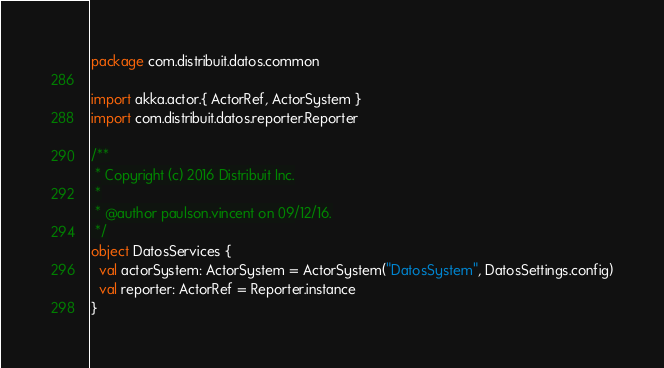<code> <loc_0><loc_0><loc_500><loc_500><_Scala_>package com.distribuit.datos.common

import akka.actor.{ ActorRef, ActorSystem }
import com.distribuit.datos.reporter.Reporter

/**
 * Copyright (c) 2016 Distribuit Inc.
 *
 * @author paulson.vincent on 09/12/16.
 */
object DatosServices {
  val actorSystem: ActorSystem = ActorSystem("DatosSystem", DatosSettings.config)
  val reporter: ActorRef = Reporter.instance
}
</code> 